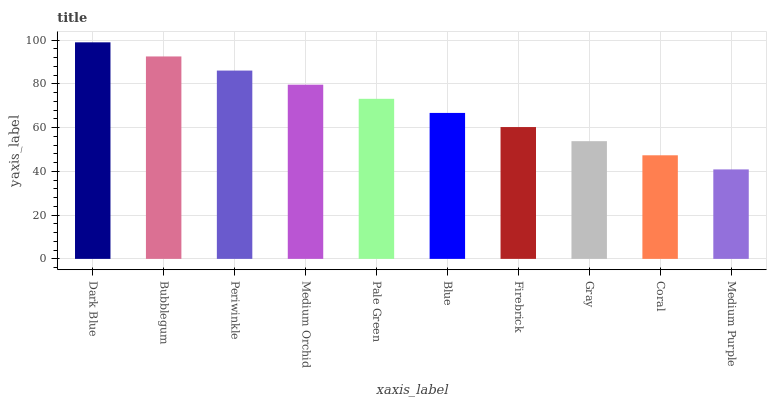Is Medium Purple the minimum?
Answer yes or no. Yes. Is Dark Blue the maximum?
Answer yes or no. Yes. Is Bubblegum the minimum?
Answer yes or no. No. Is Bubblegum the maximum?
Answer yes or no. No. Is Dark Blue greater than Bubblegum?
Answer yes or no. Yes. Is Bubblegum less than Dark Blue?
Answer yes or no. Yes. Is Bubblegum greater than Dark Blue?
Answer yes or no. No. Is Dark Blue less than Bubblegum?
Answer yes or no. No. Is Pale Green the high median?
Answer yes or no. Yes. Is Blue the low median?
Answer yes or no. Yes. Is Periwinkle the high median?
Answer yes or no. No. Is Medium Purple the low median?
Answer yes or no. No. 